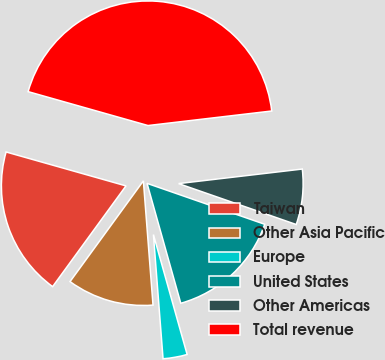Convert chart. <chart><loc_0><loc_0><loc_500><loc_500><pie_chart><fcel>Taiwan<fcel>Other Asia Pacific<fcel>Europe<fcel>United States<fcel>Other Americas<fcel>Total revenue<nl><fcel>19.37%<fcel>11.25%<fcel>3.13%<fcel>15.31%<fcel>7.19%<fcel>43.75%<nl></chart> 